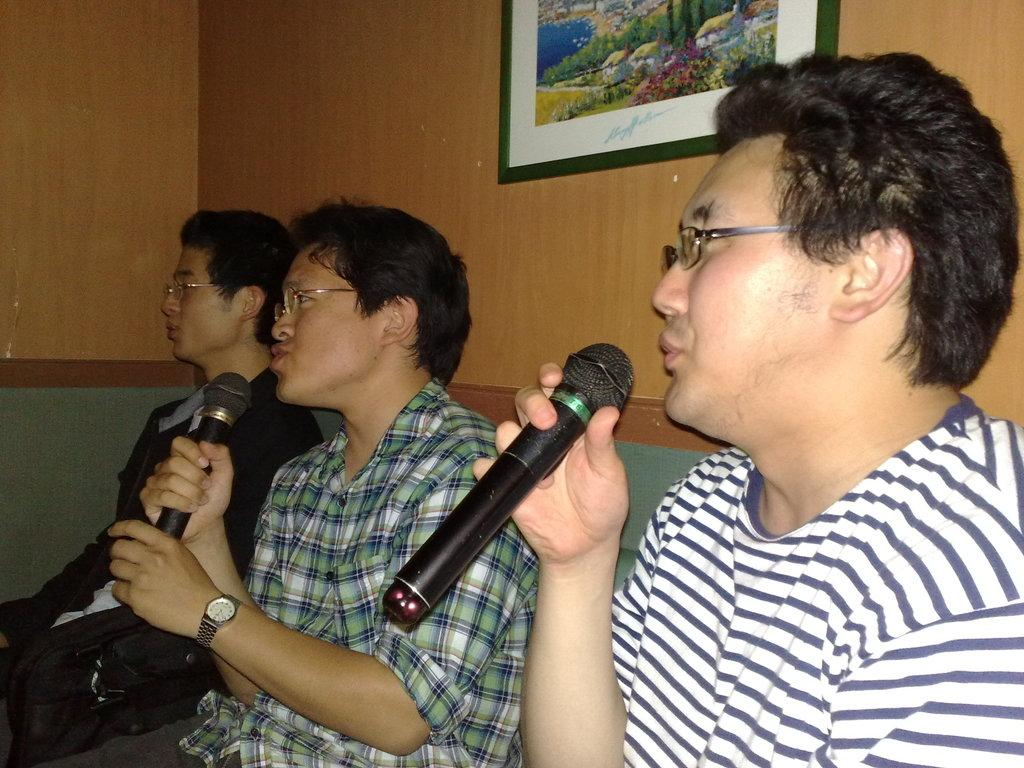How many people are in the image? There are three persons in the image. What are the persons doing in the image? The persons are sitting and holding microphones. What can be seen in the background of the image? There is a wall in the background of the image. Is there anything on the wall in the image? Yes, there is a photo frame on the wall. What type of kite is being exchanged between the persons in the image? There is no kite present in the image, nor is there any exchange happening between the persons. What is the plot of the story being told by the persons in the image? The image does not depict a story being told, so there is no plot to describe. 